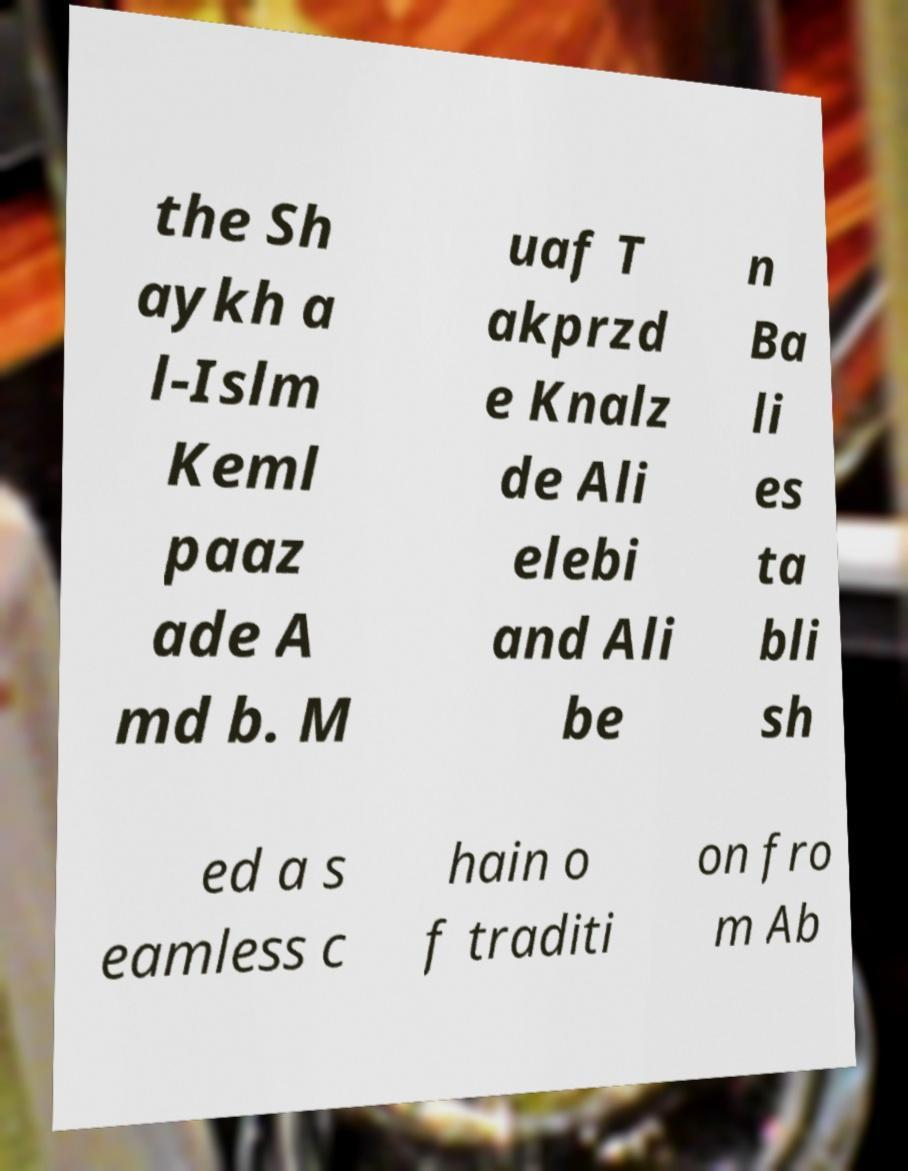For documentation purposes, I need the text within this image transcribed. Could you provide that? the Sh aykh a l-Islm Keml paaz ade A md b. M uaf T akprzd e Knalz de Ali elebi and Ali be n Ba li es ta bli sh ed a s eamless c hain o f traditi on fro m Ab 